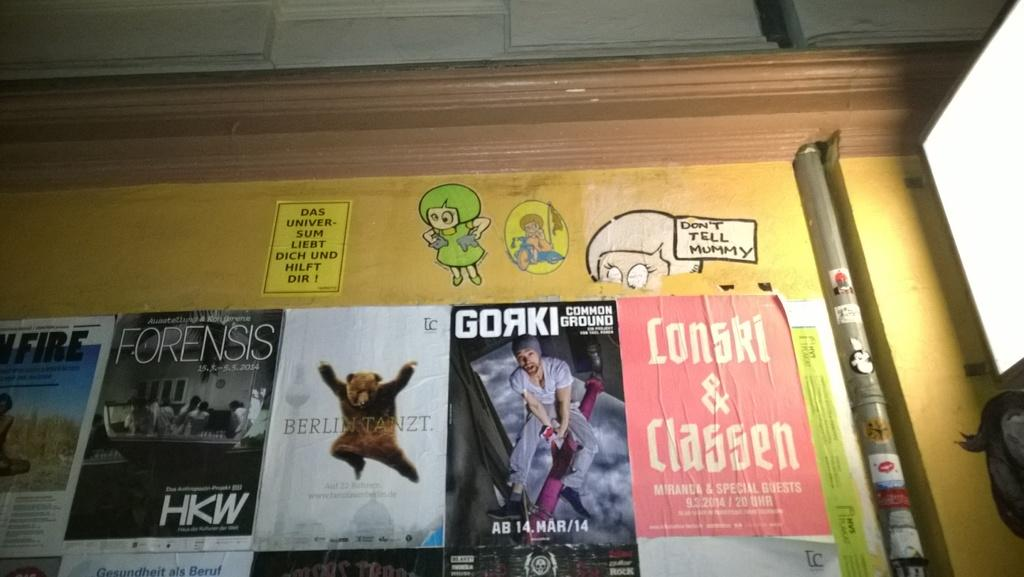<image>
Summarize the visual content of the image. One of the stickers at the top says don't tell mummy. 